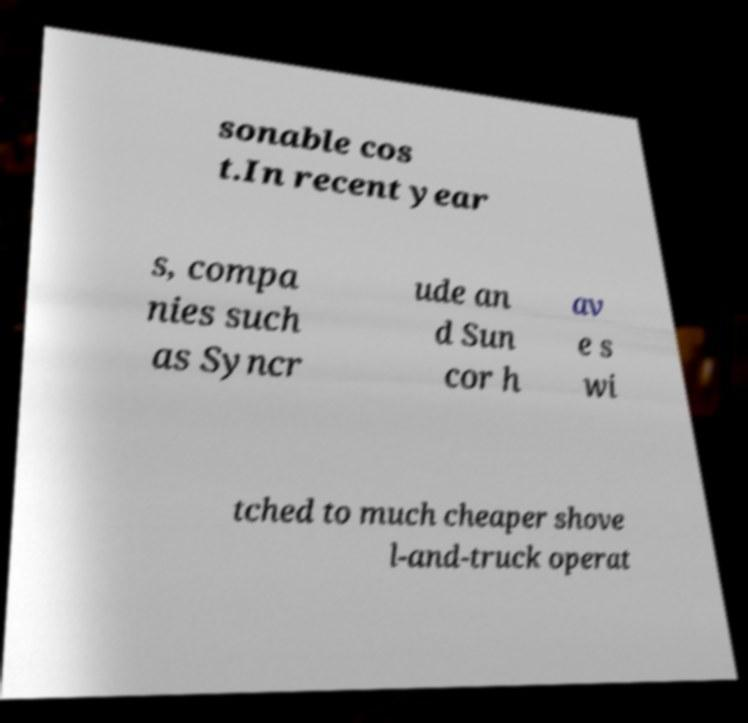Can you read and provide the text displayed in the image?This photo seems to have some interesting text. Can you extract and type it out for me? sonable cos t.In recent year s, compa nies such as Syncr ude an d Sun cor h av e s wi tched to much cheaper shove l-and-truck operat 